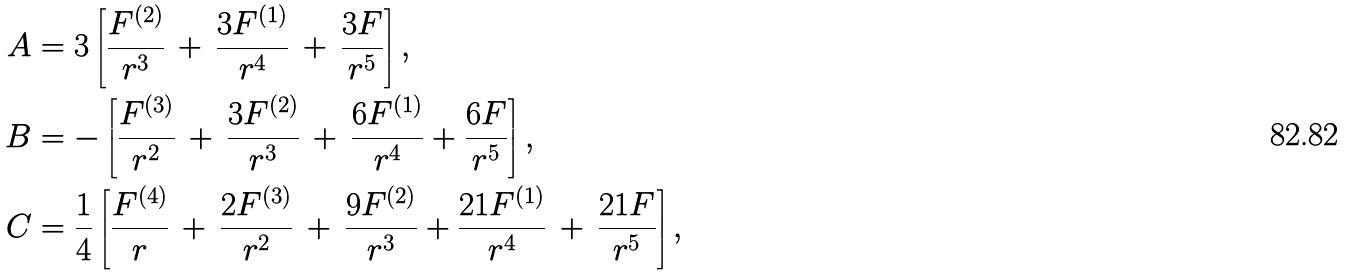Convert formula to latex. <formula><loc_0><loc_0><loc_500><loc_500>A & = 3 \left [ \frac { F ^ { ( 2 ) } } { r ^ { 3 } } \, + \, \frac { 3 F ^ { ( 1 ) } } { r ^ { 4 } } \, + \, \frac { 3 F } { r ^ { 5 } } \right ] , \\ B & = - \left [ \frac { F ^ { ( 3 ) } } { r ^ { 2 } } \, + \, \frac { 3 F ^ { ( 2 ) } } { r ^ { 3 } } \, + \, \frac { 6 F ^ { ( 1 ) } } { r ^ { 4 } } + \frac { 6 F } { r ^ { 5 } } \right ] , \\ C & = \frac { 1 } { 4 } \left [ \frac { F ^ { ( 4 ) } } { r } \, + \, \frac { 2 F ^ { ( 3 ) } } { r ^ { 2 } } \, + \, \frac { 9 F ^ { ( 2 ) } } { r ^ { 3 } } + \frac { 2 1 F ^ { ( 1 ) } } { r ^ { 4 } } \, + \, \frac { 2 1 F } { r ^ { 5 } } \right ] ,</formula> 